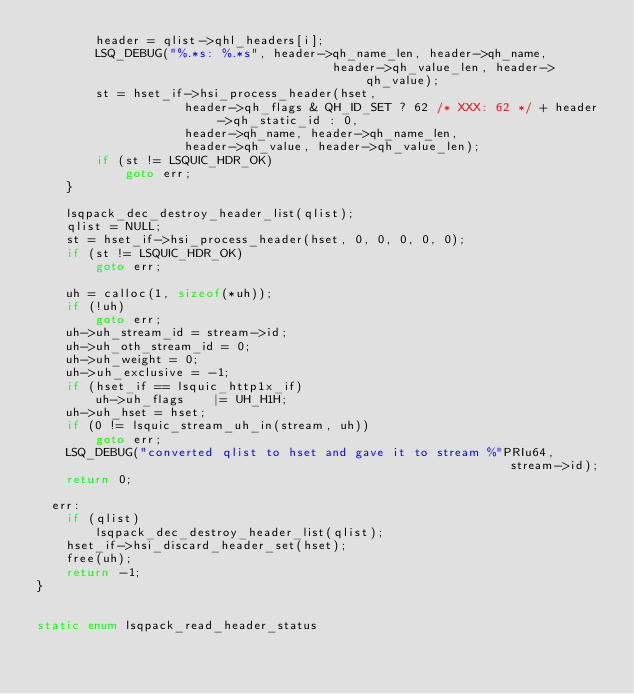Convert code to text. <code><loc_0><loc_0><loc_500><loc_500><_C_>        header = qlist->qhl_headers[i];
        LSQ_DEBUG("%.*s: %.*s", header->qh_name_len, header->qh_name,
                                        header->qh_value_len, header->qh_value);
        st = hset_if->hsi_process_header(hset,
                    header->qh_flags & QH_ID_SET ? 62 /* XXX: 62 */ + header->qh_static_id : 0,
                    header->qh_name, header->qh_name_len,
                    header->qh_value, header->qh_value_len);
        if (st != LSQUIC_HDR_OK)
            goto err;
    }

    lsqpack_dec_destroy_header_list(qlist);
    qlist = NULL;
    st = hset_if->hsi_process_header(hset, 0, 0, 0, 0, 0);
    if (st != LSQUIC_HDR_OK)
        goto err;

    uh = calloc(1, sizeof(*uh));
    if (!uh)
        goto err;
    uh->uh_stream_id = stream->id;
    uh->uh_oth_stream_id = 0;
    uh->uh_weight = 0;
    uh->uh_exclusive = -1;
    if (hset_if == lsquic_http1x_if)
        uh->uh_flags    |= UH_H1H;
    uh->uh_hset = hset;
    if (0 != lsquic_stream_uh_in(stream, uh))
        goto err;
    LSQ_DEBUG("converted qlist to hset and gave it to stream %"PRIu64,
                                                                stream->id);
    return 0;

  err:
    if (qlist)
        lsqpack_dec_destroy_header_list(qlist);
    hset_if->hsi_discard_header_set(hset);
    free(uh);
    return -1;
}


static enum lsqpack_read_header_status</code> 